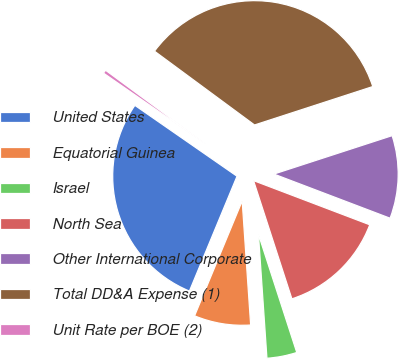<chart> <loc_0><loc_0><loc_500><loc_500><pie_chart><fcel>United States<fcel>Equatorial Guinea<fcel>Israel<fcel>North Sea<fcel>Other International Corporate<fcel>Total DD&A Expense (1)<fcel>Unit Rate per BOE (2)<nl><fcel>28.4%<fcel>7.34%<fcel>3.9%<fcel>14.23%<fcel>10.78%<fcel>34.88%<fcel>0.46%<nl></chart> 